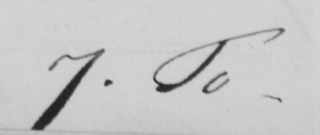Can you tell me what this handwritten text says? 7. To 